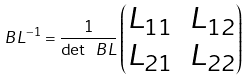Convert formula to latex. <formula><loc_0><loc_0><loc_500><loc_500>\ B L ^ { - 1 } = \frac { 1 } { \det \ B L } \begin{pmatrix} L _ { 1 1 } & L _ { 1 2 } \\ L _ { 2 1 } & L _ { 2 2 } \end{pmatrix}</formula> 